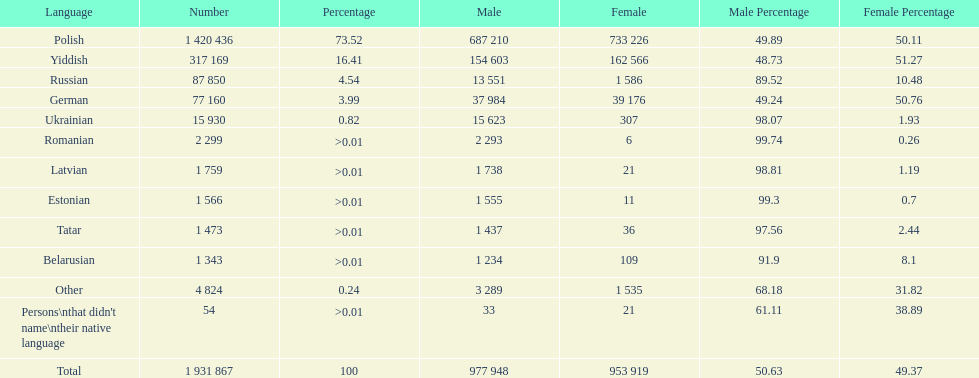What is the highest percentage of speakers other than polish? Yiddish. 